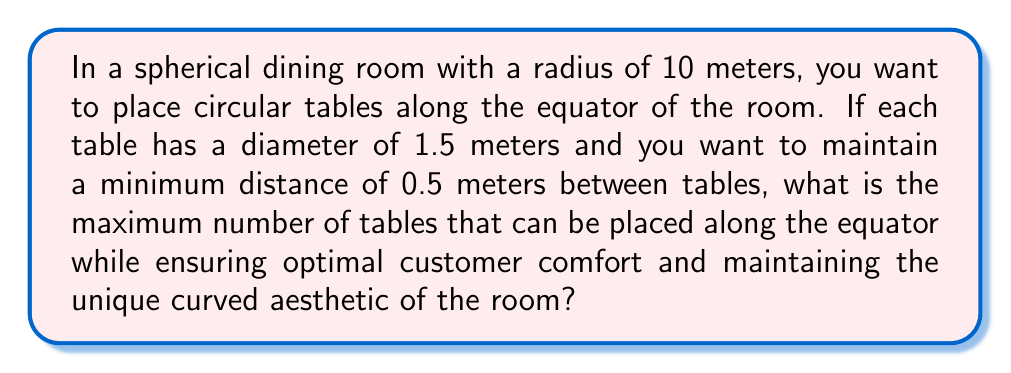Can you answer this question? Let's approach this step-by-step:

1) First, we need to calculate the circumference of the equator of the spherical room. The formula for the circumference of a great circle on a sphere is:

   $$C = 2\pi r$$

   where $r$ is the radius of the sphere.

2) Given the radius is 10 meters:

   $$C = 2\pi(10) = 20\pi \approx 62.83 \text{ meters}$$

3) Now, we need to consider the space each table occupies along this circumference. Each table has:
   - Diameter: 1.5 meters
   - Required gap on each side: 0.5 meters
   
   Total space per table: $1.5 + 0.5 + 0.5 = 2.5 \text{ meters}$

4) To find the maximum number of tables, we divide the circumference by the space per table:

   $$\text{Number of tables} = \frac{62.83}{2.5} \approx 25.13$$

5) Since we can't have a fractional table, we round down to the nearest whole number.

[asy]
import geometry;

size(200);
pair O = (0,0);
real R = 10;
draw(circle(O,R), blue);
real tableAngle = 360/25;
for(int i=0; i<25; ++i) {
  pair P = R*dir(i*tableAngle);
  draw(circle(P, 0.75), red);
}
label("Spherical Room", O, fontsize(10));
[/asy]

This arrangement ensures optimal use of space while maintaining customer comfort and preserving the unique curved aesthetic of the room, which could be a great talking point for positive reviews.
Answer: 25 tables 